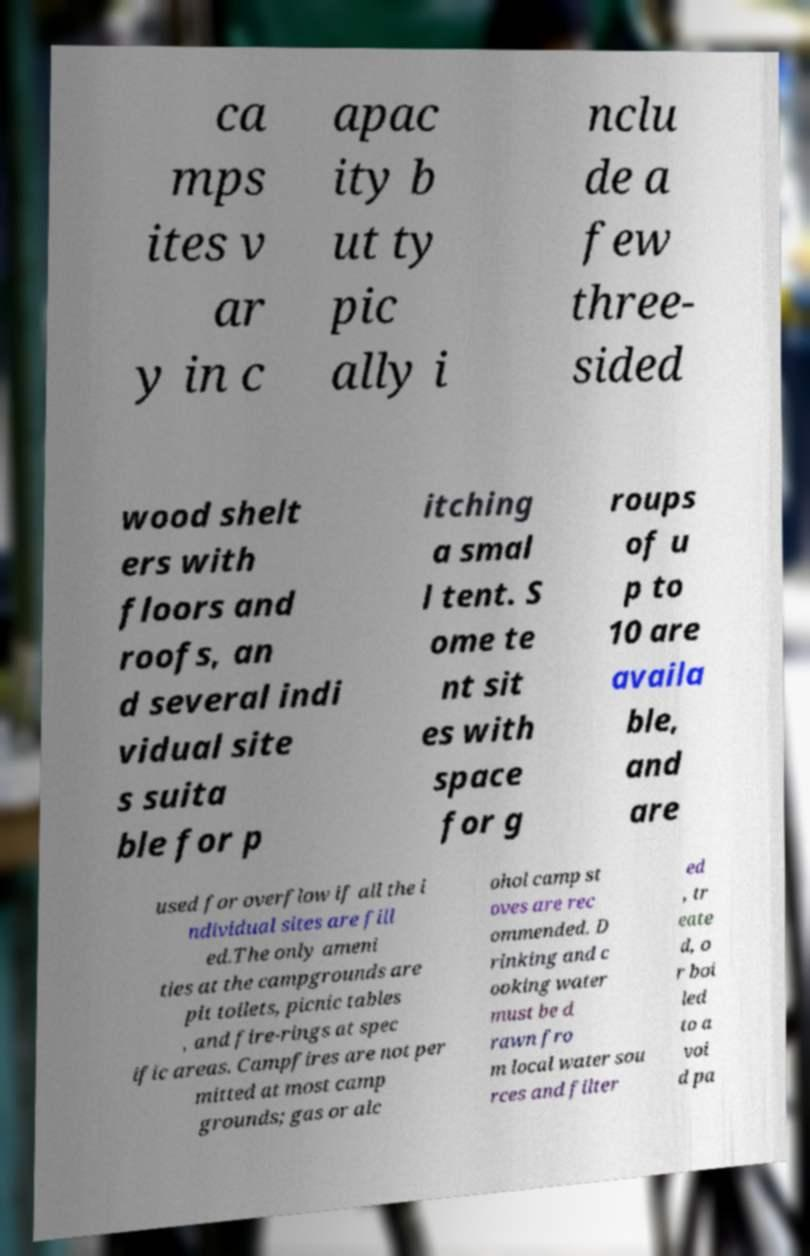For documentation purposes, I need the text within this image transcribed. Could you provide that? ca mps ites v ar y in c apac ity b ut ty pic ally i nclu de a few three- sided wood shelt ers with floors and roofs, an d several indi vidual site s suita ble for p itching a smal l tent. S ome te nt sit es with space for g roups of u p to 10 are availa ble, and are used for overflow if all the i ndividual sites are fill ed.The only ameni ties at the campgrounds are pit toilets, picnic tables , and fire-rings at spec ific areas. Campfires are not per mitted at most camp grounds; gas or alc ohol camp st oves are rec ommended. D rinking and c ooking water must be d rawn fro m local water sou rces and filter ed , tr eate d, o r boi led to a voi d pa 